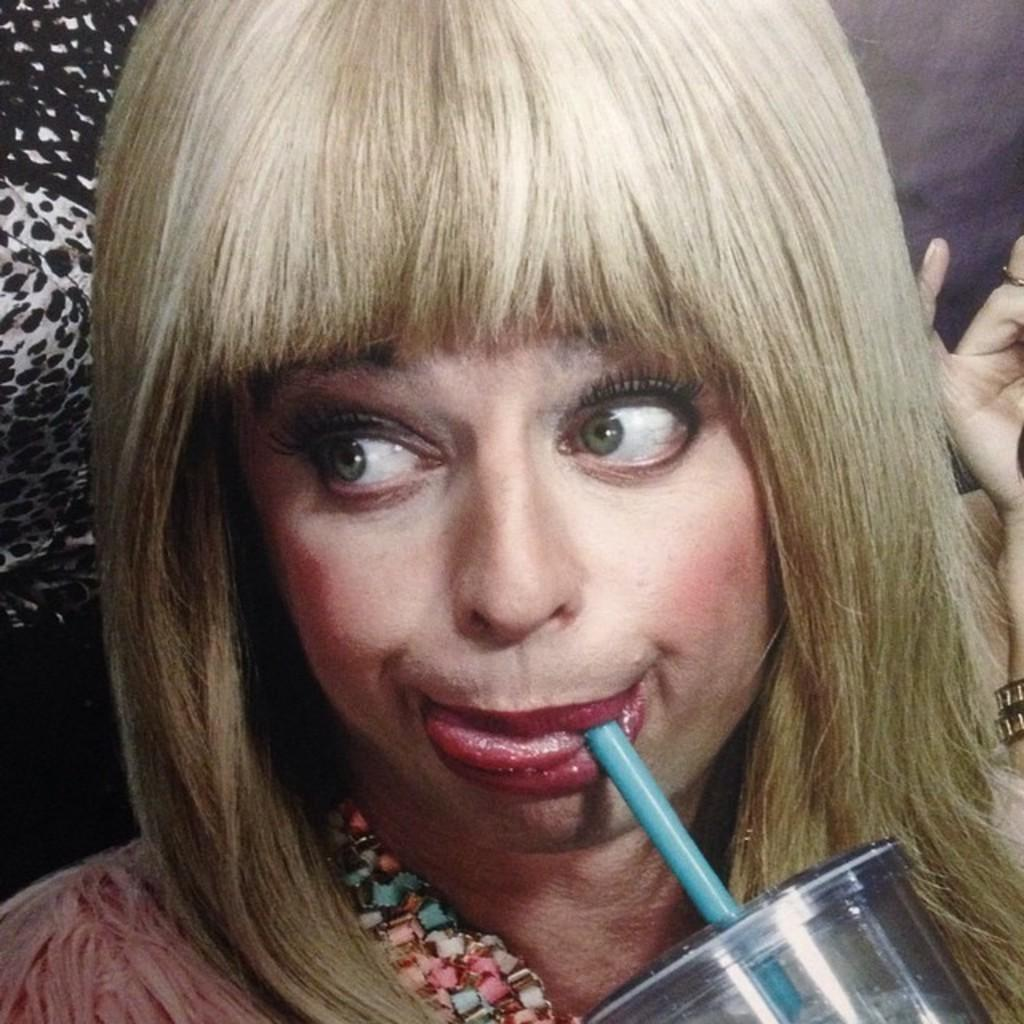What is the main subject of the image? The main subject of the image is a group of people. Can you describe the woman in the image? There is a woman in the middle of the image, and she is drinking with the help of a straw. How many tubs are visible in the image? There are no tubs present in the image. What type of goat can be seen interacting with the woman in the image? There is no goat present in the image; it only features a group of people. 